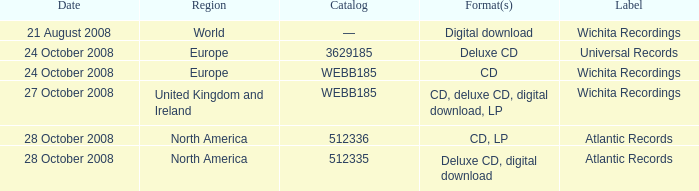Which date was associated with the release in Europe on the Wichita Recordings label? 24 October 2008. 